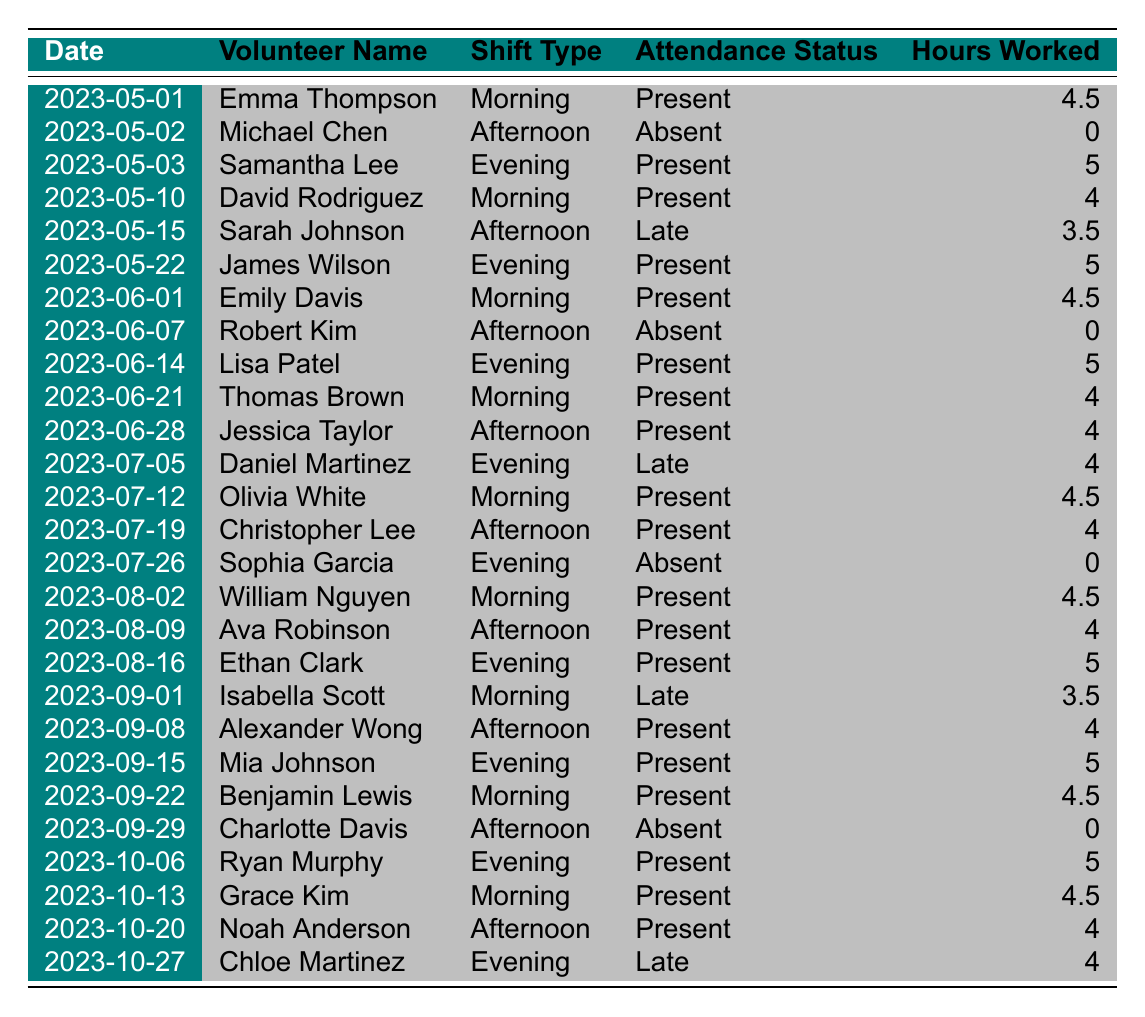What is the average number of hours worked by volunteers in the surgical ward? To find the average, we sum the total hours worked and divide by the number of entries. The total hours is (4.5 + 0 + 5 + 4 + 3.5 + 5 + 4.5 + 0 + 5 + 4 + 4 + 4 + 4.5 + 4 + 0 + 4.5 + 4 + 5 + 3.5 + 4 + 5 + 4.5 + 0 + 5 + 4.5 + 4 + 4) = 85.5. There are 27 entries, so the average is 85.5 / 27 ≈ 3.17.
Answer: 3.17 How many times was a volunteer late for their shift? By checking the Attendance Status column, we count the entries marked as "Late." There are three instances: Sarah Johnson on May 15, Daniel Martinez on July 5, and Isabella Scott on September 1.
Answer: 3 Which volunteer had the highest number of hours worked on a single day? We examine the Hours Worked column for the highest value. The maximum hour entry is 5, which corresponds to three instances: Samantha Lee on May 3, James Wilson on May 22, and Ethan Clark on August 16.
Answer: 5 Did any volunteers have perfect attendance in the month of June? We check the Attendance Status for each volunteer in June. Robert Kim was absent on June 7, indicating that not all volunteers had perfect attendance that month.
Answer: No Which shift type had the highest attendance rate? First, we categorize attendance by shift. Morning: 10 present, 1 absent; Afternoon: 8 present, 3 absent; Evening: 7 present, 2 absent. The attendance rates are 10/11 (90.91%), 8/11 (72.73%), and 7/9 (77.78%). The morning shift has the highest attendance rate.
Answer: Morning What is the total number of hours worked by volunteers in the surgical ward in September? We add up the Hours Worked for September (3.5 + 4 + 5 + 4.5 + 0 + 5 = 22).
Answer: 22 How many volunteers were absent at least once during the 6 months? By checking for "Absent" status in the Attendance Status column, we find Michael Chen, Robert Kim, Sophia Garcia, and Charlotte Davis—four distinct volunteers—who had absentee records.
Answer: 4 Identify the volunteer who worked the most shifts. We count the occurrences of each volunteer's name. Emma Thompson, with 4 shifts; followed by others with fewer entries. Emma Thompson has the highest total, indicating she worked the most.
Answer: Emma Thompson In which month did the highest number of evening shifts occur? By analyzing the Evening shifts: May (2), June (3), July (2), August (3), September (2), and October (1). June had the highest number of evening shifts (3).
Answer: June What percentage of shifts had volunteers marked as "Absent"? There are 27 total shifts, with 6 marked as "Absent." The percentage is (6/27) * 100 = 22.22%.
Answer: 22.22% 